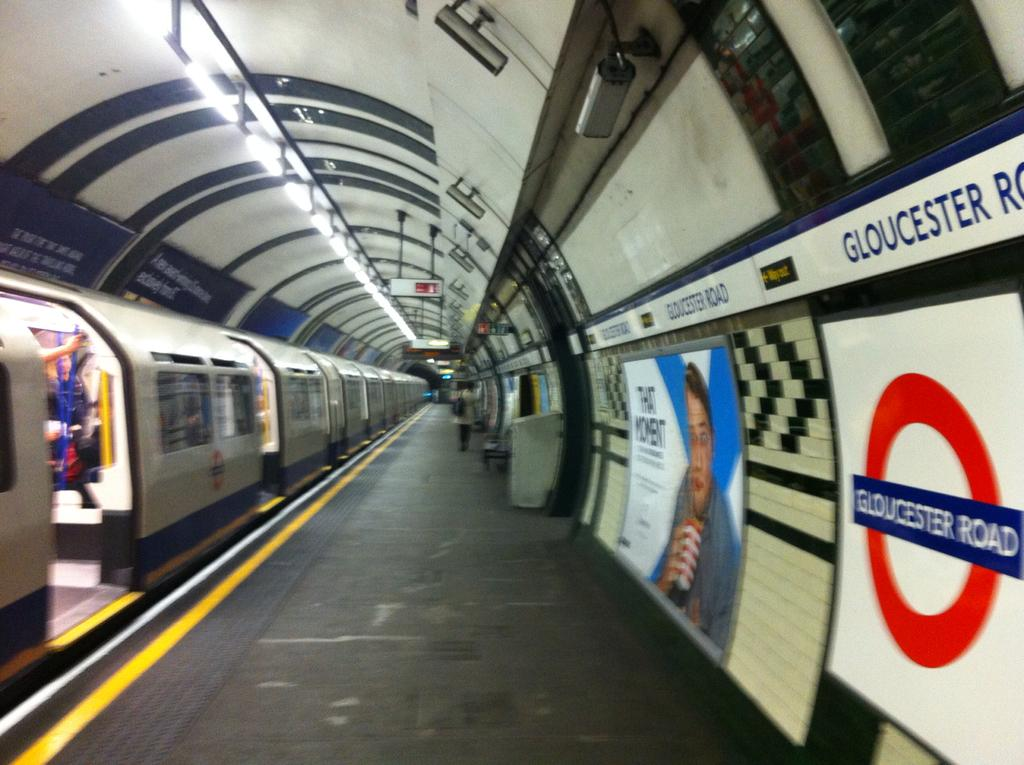<image>
Write a terse but informative summary of the picture. A sign on the wall of an underground train station says GLOUCESTER ROAD. 